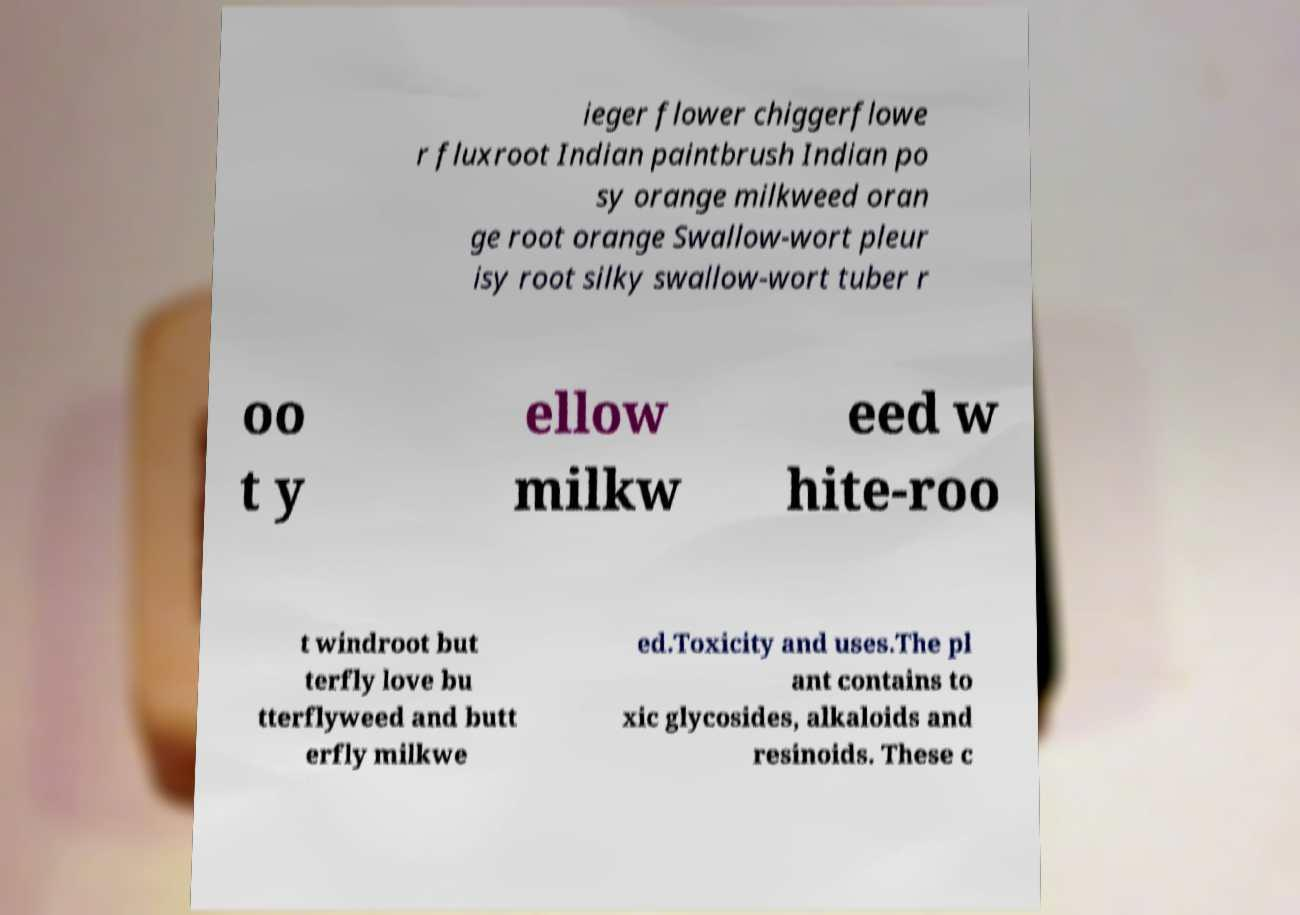Please identify and transcribe the text found in this image. ieger flower chiggerflowe r fluxroot Indian paintbrush Indian po sy orange milkweed oran ge root orange Swallow-wort pleur isy root silky swallow-wort tuber r oo t y ellow milkw eed w hite-roo t windroot but terfly love bu tterflyweed and butt erfly milkwe ed.Toxicity and uses.The pl ant contains to xic glycosides, alkaloids and resinoids. These c 